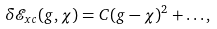Convert formula to latex. <formula><loc_0><loc_0><loc_500><loc_500>\delta \mathcal { E } _ { x c } ( g , \chi ) = C ( g - \chi ) ^ { 2 } + \dots ,</formula> 